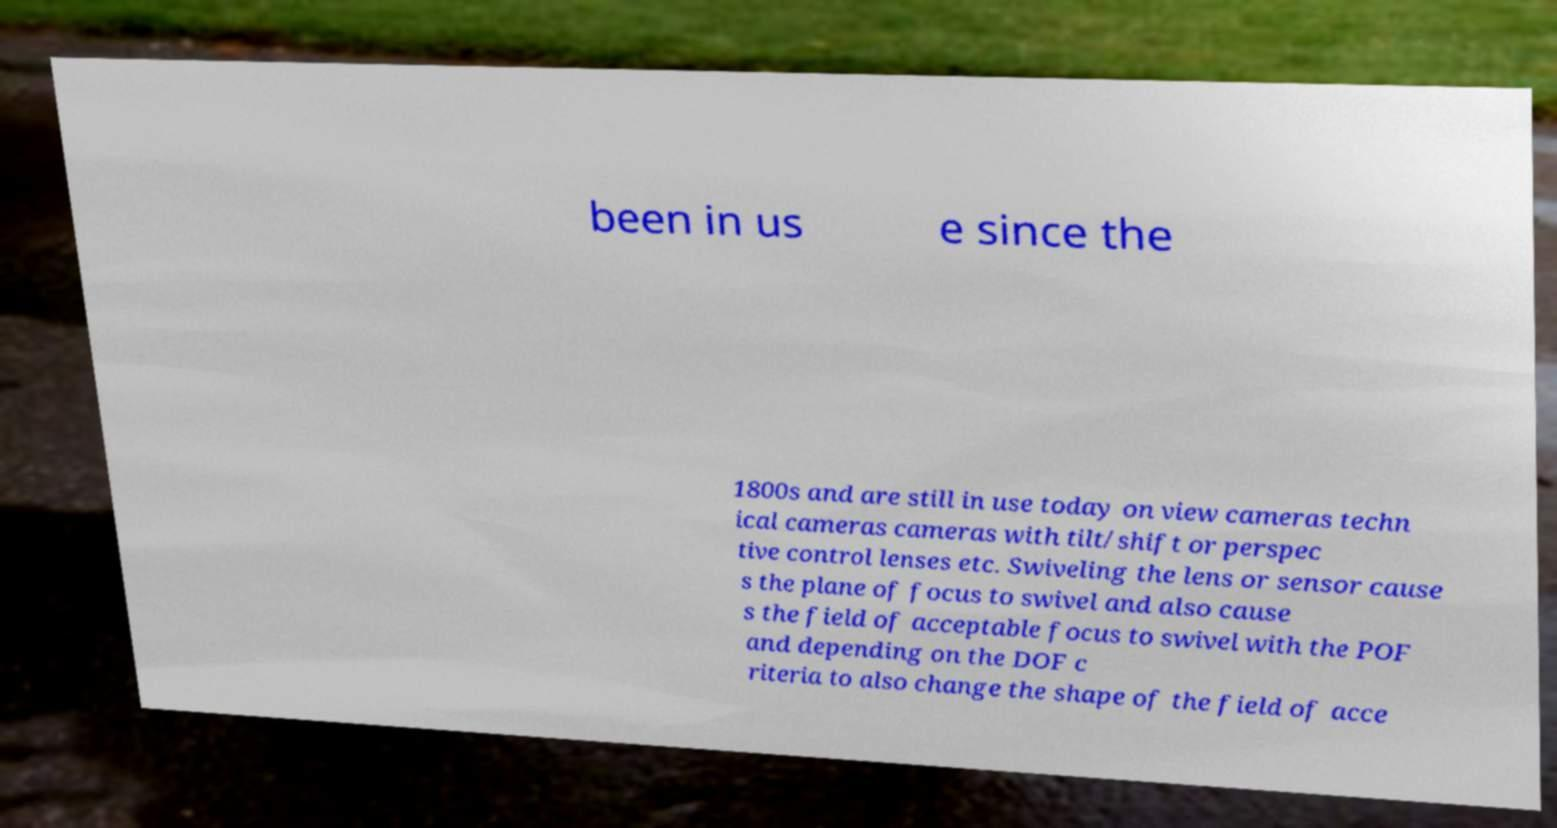There's text embedded in this image that I need extracted. Can you transcribe it verbatim? been in us e since the 1800s and are still in use today on view cameras techn ical cameras cameras with tilt/shift or perspec tive control lenses etc. Swiveling the lens or sensor cause s the plane of focus to swivel and also cause s the field of acceptable focus to swivel with the POF and depending on the DOF c riteria to also change the shape of the field of acce 